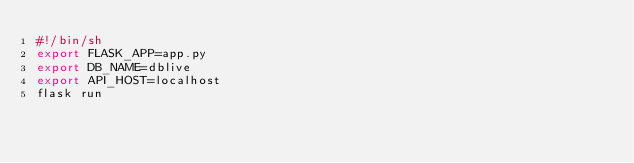Convert code to text. <code><loc_0><loc_0><loc_500><loc_500><_Bash_>#!/bin/sh
export FLASK_APP=app.py
export DB_NAME=dblive
export API_HOST=localhost
flask run
</code> 